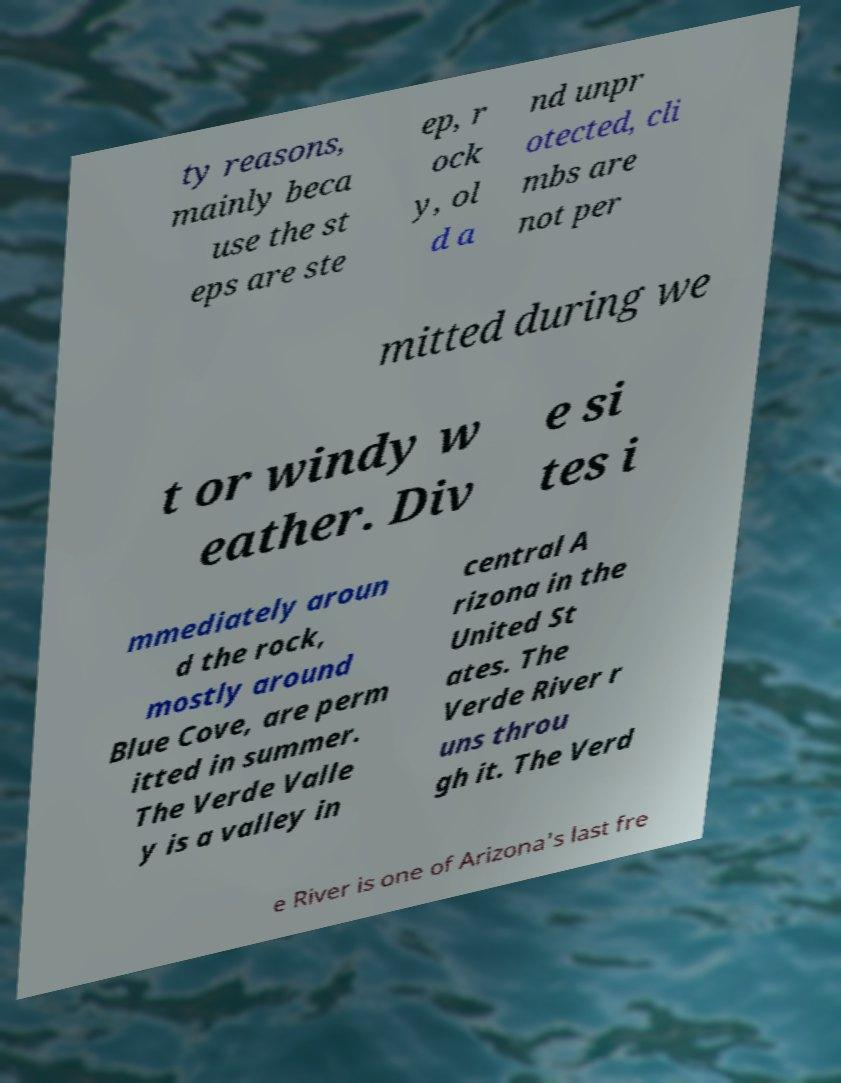Please read and relay the text visible in this image. What does it say? ty reasons, mainly beca use the st eps are ste ep, r ock y, ol d a nd unpr otected, cli mbs are not per mitted during we t or windy w eather. Div e si tes i mmediately aroun d the rock, mostly around Blue Cove, are perm itted in summer. The Verde Valle y is a valley in central A rizona in the United St ates. The Verde River r uns throu gh it. The Verd e River is one of Arizona's last fre 